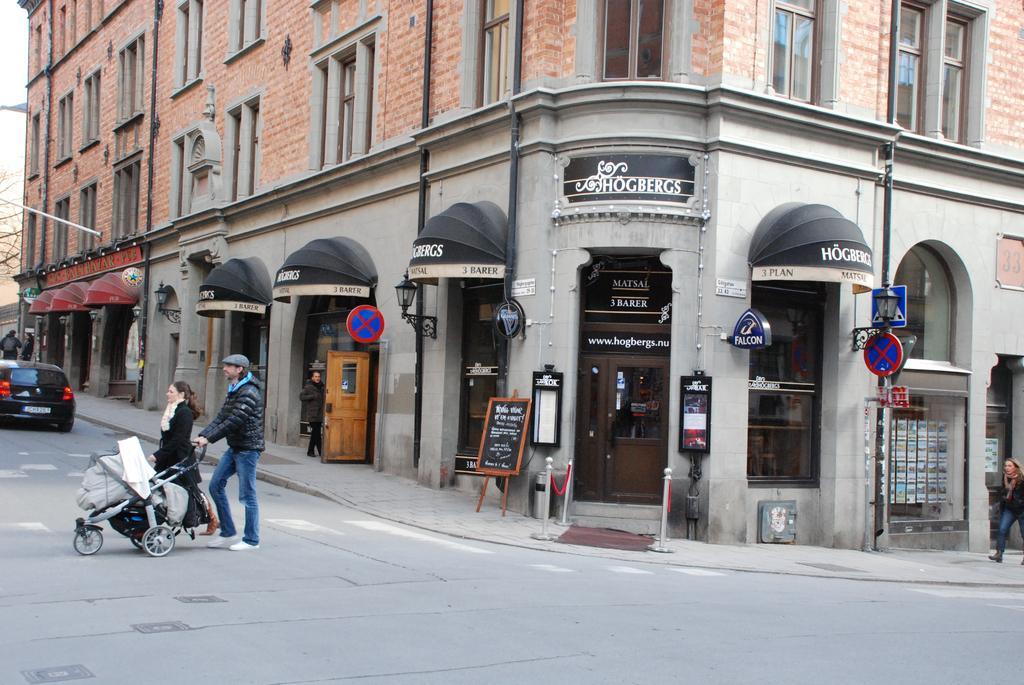How would you summarize this image in a sentence or two? In this picture I can see a vehicle on the road, there are group of people standing, there is a person holding a stroller, and in the background there are boards, lights, rope barriers and there is a building with windows. 